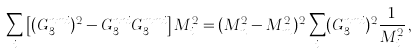Convert formula to latex. <formula><loc_0><loc_0><loc_500><loc_500>\sum _ { i } \left [ ( G _ { 3 } ^ { n m i } ) ^ { 2 } - G _ { 3 } ^ { n n i } G _ { 3 } ^ { m m i } \right ] M _ { i } ^ { 2 } = ( M _ { n } ^ { 2 } - M _ { m } ^ { 2 } ) ^ { 2 } \sum _ { i } ( G _ { 3 } ^ { n m i } ) ^ { 2 } \frac { 1 } { M _ { i } ^ { 2 } } \, ,</formula> 